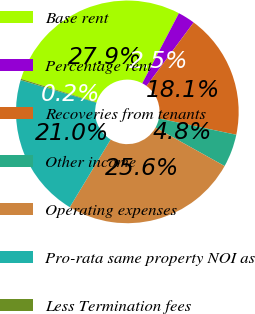Convert chart. <chart><loc_0><loc_0><loc_500><loc_500><pie_chart><fcel>Base rent<fcel>Percentage rent<fcel>Recoveries from tenants<fcel>Other income<fcel>Operating expenses<fcel>Pro-rata same property NOI as<fcel>Less Termination fees<nl><fcel>27.87%<fcel>2.49%<fcel>18.14%<fcel>4.79%<fcel>25.56%<fcel>20.96%<fcel>0.19%<nl></chart> 